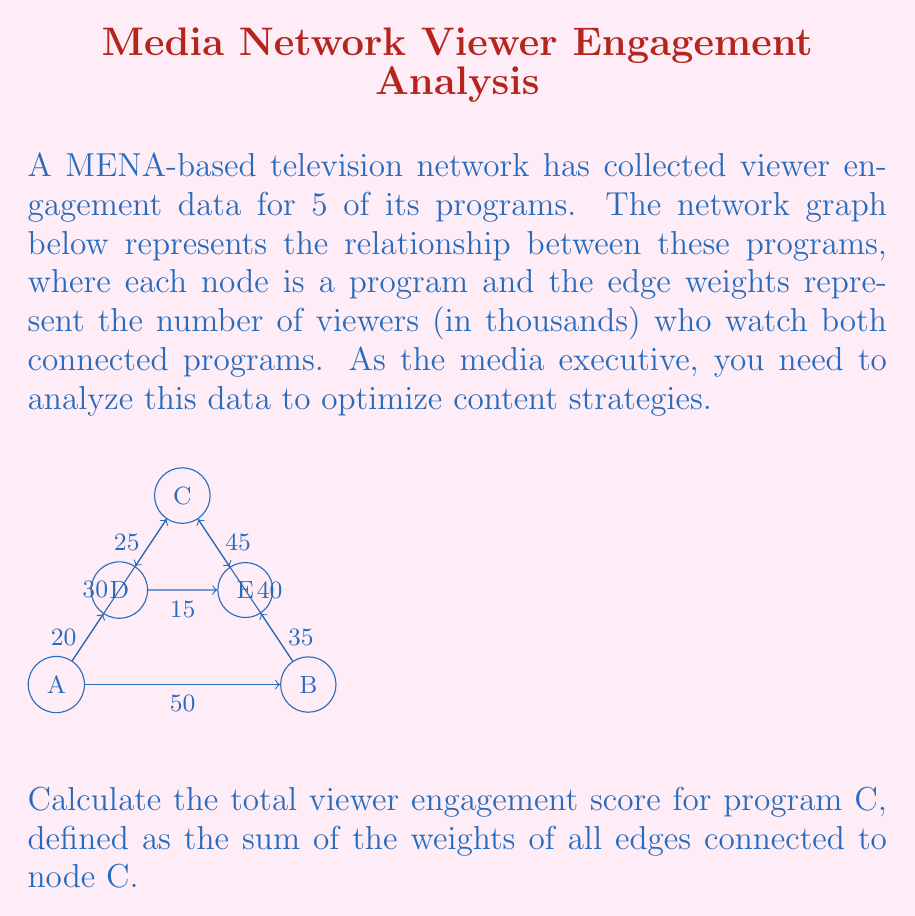Can you solve this math problem? To calculate the total viewer engagement score for program C, we need to sum up the weights of all edges connected to node C in the network graph. Let's identify these edges and their weights:

1. Edge C-A: weight = 30
2. Edge C-B: weight = 40
3. Edge C-D: weight = 25
4. Edge C-E: weight = 45

Now, let's sum these weights:

$$ \text{Total viewer engagement score} = 30 + 40 + 25 + 45 $$

$$ = 140 $$

Therefore, the total viewer engagement score for program C is 140 thousand viewers.

This score indicates that program C has a strong connection with other programs in the network, as it shares a total of 140,000 viewers with its neighboring programs. As a media executive, this information can be used to make decisions about cross-promotion, scheduling, or content development to further leverage the popularity of program C.
Answer: 140 thousand viewers 